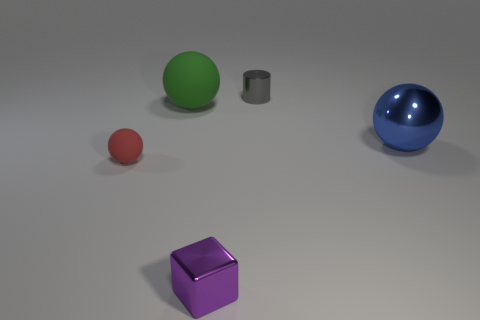Add 2 small purple things. How many objects exist? 7 Subtract all balls. How many objects are left? 2 Add 4 large matte things. How many large matte things exist? 5 Subtract 0 red blocks. How many objects are left? 5 Subtract all big cyan metallic things. Subtract all large green matte objects. How many objects are left? 4 Add 2 tiny matte balls. How many tiny matte balls are left? 3 